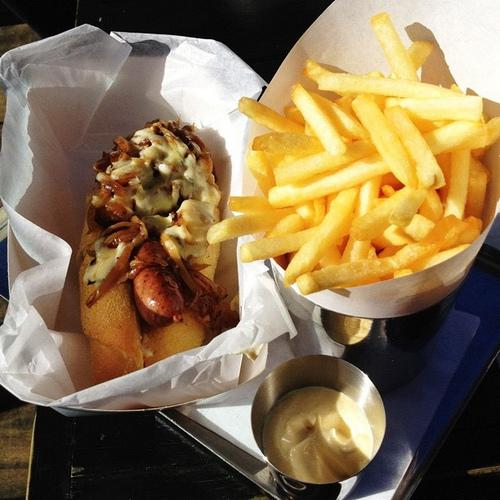Question: what is in the picture?
Choices:
A. Food.
B. Dogs.
C. Houses.
D. A swimming pool.
Answer with the letter. Answer: A Question: what sandwich is shown?
Choices:
A. A pastrami sandwich.
B. A peanut butter and jelly sandwich.
C. An egg salad sandwich.
D. A hot dog sandwich.
Answer with the letter. Answer: D Question: what is in the small bowl?
Choices:
A. Peanuts.
B. Mayonnaise.
C. Cat food.
D. Milk.
Answer with the letter. Answer: B Question: what is in the basket next to the hotdog?
Choices:
A. Onion rings.
B. Potato chips.
C. French fries.
D. Chicken fingers.
Answer with the letter. Answer: C 